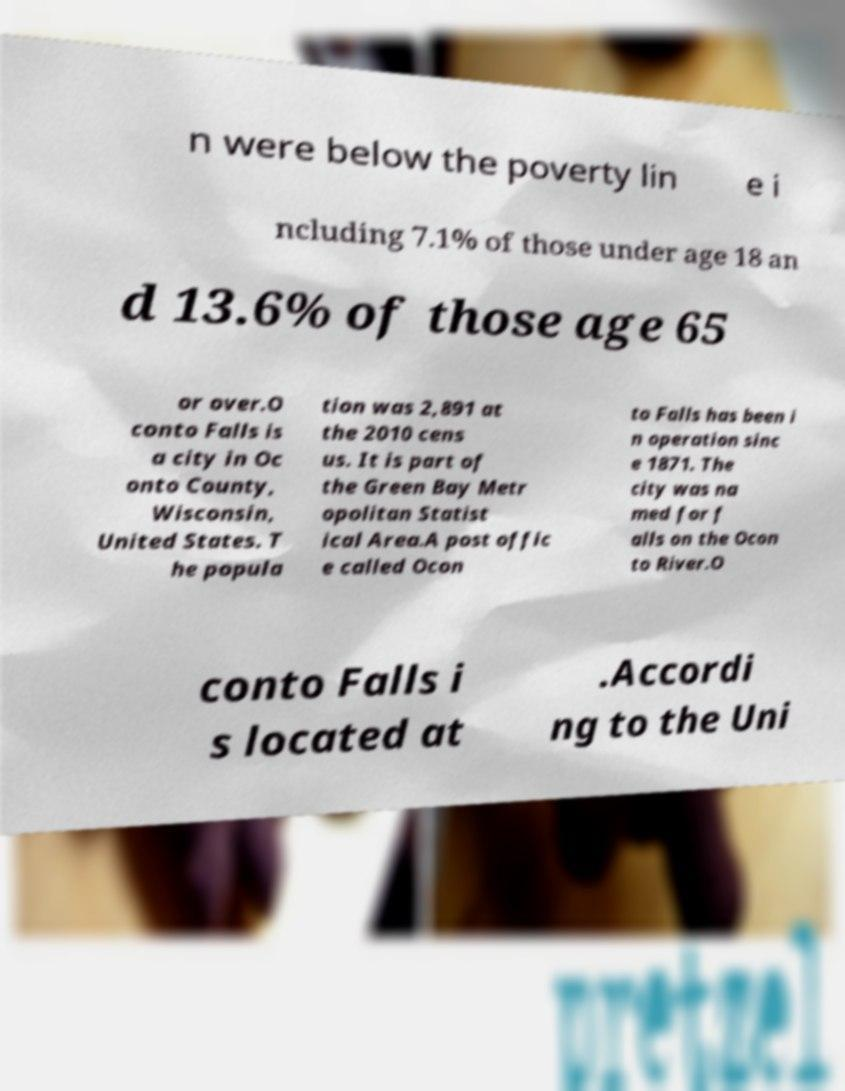Could you assist in decoding the text presented in this image and type it out clearly? n were below the poverty lin e i ncluding 7.1% of those under age 18 an d 13.6% of those age 65 or over.O conto Falls is a city in Oc onto County, Wisconsin, United States. T he popula tion was 2,891 at the 2010 cens us. It is part of the Green Bay Metr opolitan Statist ical Area.A post offic e called Ocon to Falls has been i n operation sinc e 1871. The city was na med for f alls on the Ocon to River.O conto Falls i s located at .Accordi ng to the Uni 